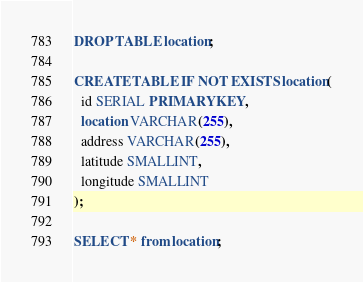<code> <loc_0><loc_0><loc_500><loc_500><_SQL_>DROP TABLE location;

CREATE TABLE IF NOT EXISTS location(
  id SERIAL PRIMARY KEY,
  location VARCHAR(255),
  address VARCHAR(255),
  latitude SMALLINT,
  longitude SMALLINT
);

SELECT * from location;</code> 